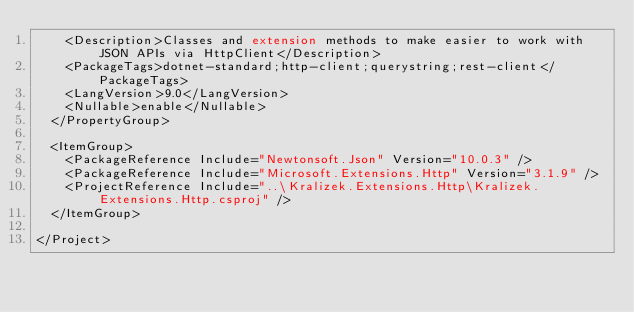Convert code to text. <code><loc_0><loc_0><loc_500><loc_500><_XML_>    <Description>Classes and extension methods to make easier to work with JSON APIs via HttpClient</Description>
    <PackageTags>dotnet-standard;http-client;querystring;rest-client</PackageTags>
    <LangVersion>9.0</LangVersion>
    <Nullable>enable</Nullable>
  </PropertyGroup>

  <ItemGroup>
    <PackageReference Include="Newtonsoft.Json" Version="10.0.3" />
    <PackageReference Include="Microsoft.Extensions.Http" Version="3.1.9" />
    <ProjectReference Include="..\Kralizek.Extensions.Http\Kralizek.Extensions.Http.csproj" />
  </ItemGroup>

</Project>
</code> 